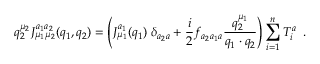<formula> <loc_0><loc_0><loc_500><loc_500>q _ { 2 } ^ { \mu _ { 2 } } J _ { \mu _ { 1 } \mu _ { 2 } } ^ { a _ { 1 } a _ { 2 } } ( q _ { 1 } , q _ { 2 } ) = \left ( J _ { \mu _ { 1 } } ^ { a _ { 1 } } ( q _ { 1 } ) \, \delta _ { a _ { 2 } a } + \frac { i } { 2 } f _ { a _ { 2 } a _ { 1 } a } \frac { q _ { 2 } ^ { \mu _ { 1 } } } { q _ { 1 } \cdot q _ { 2 } } \right ) \sum _ { i = 1 } ^ { n } T _ { i } ^ { a } \, .</formula> 